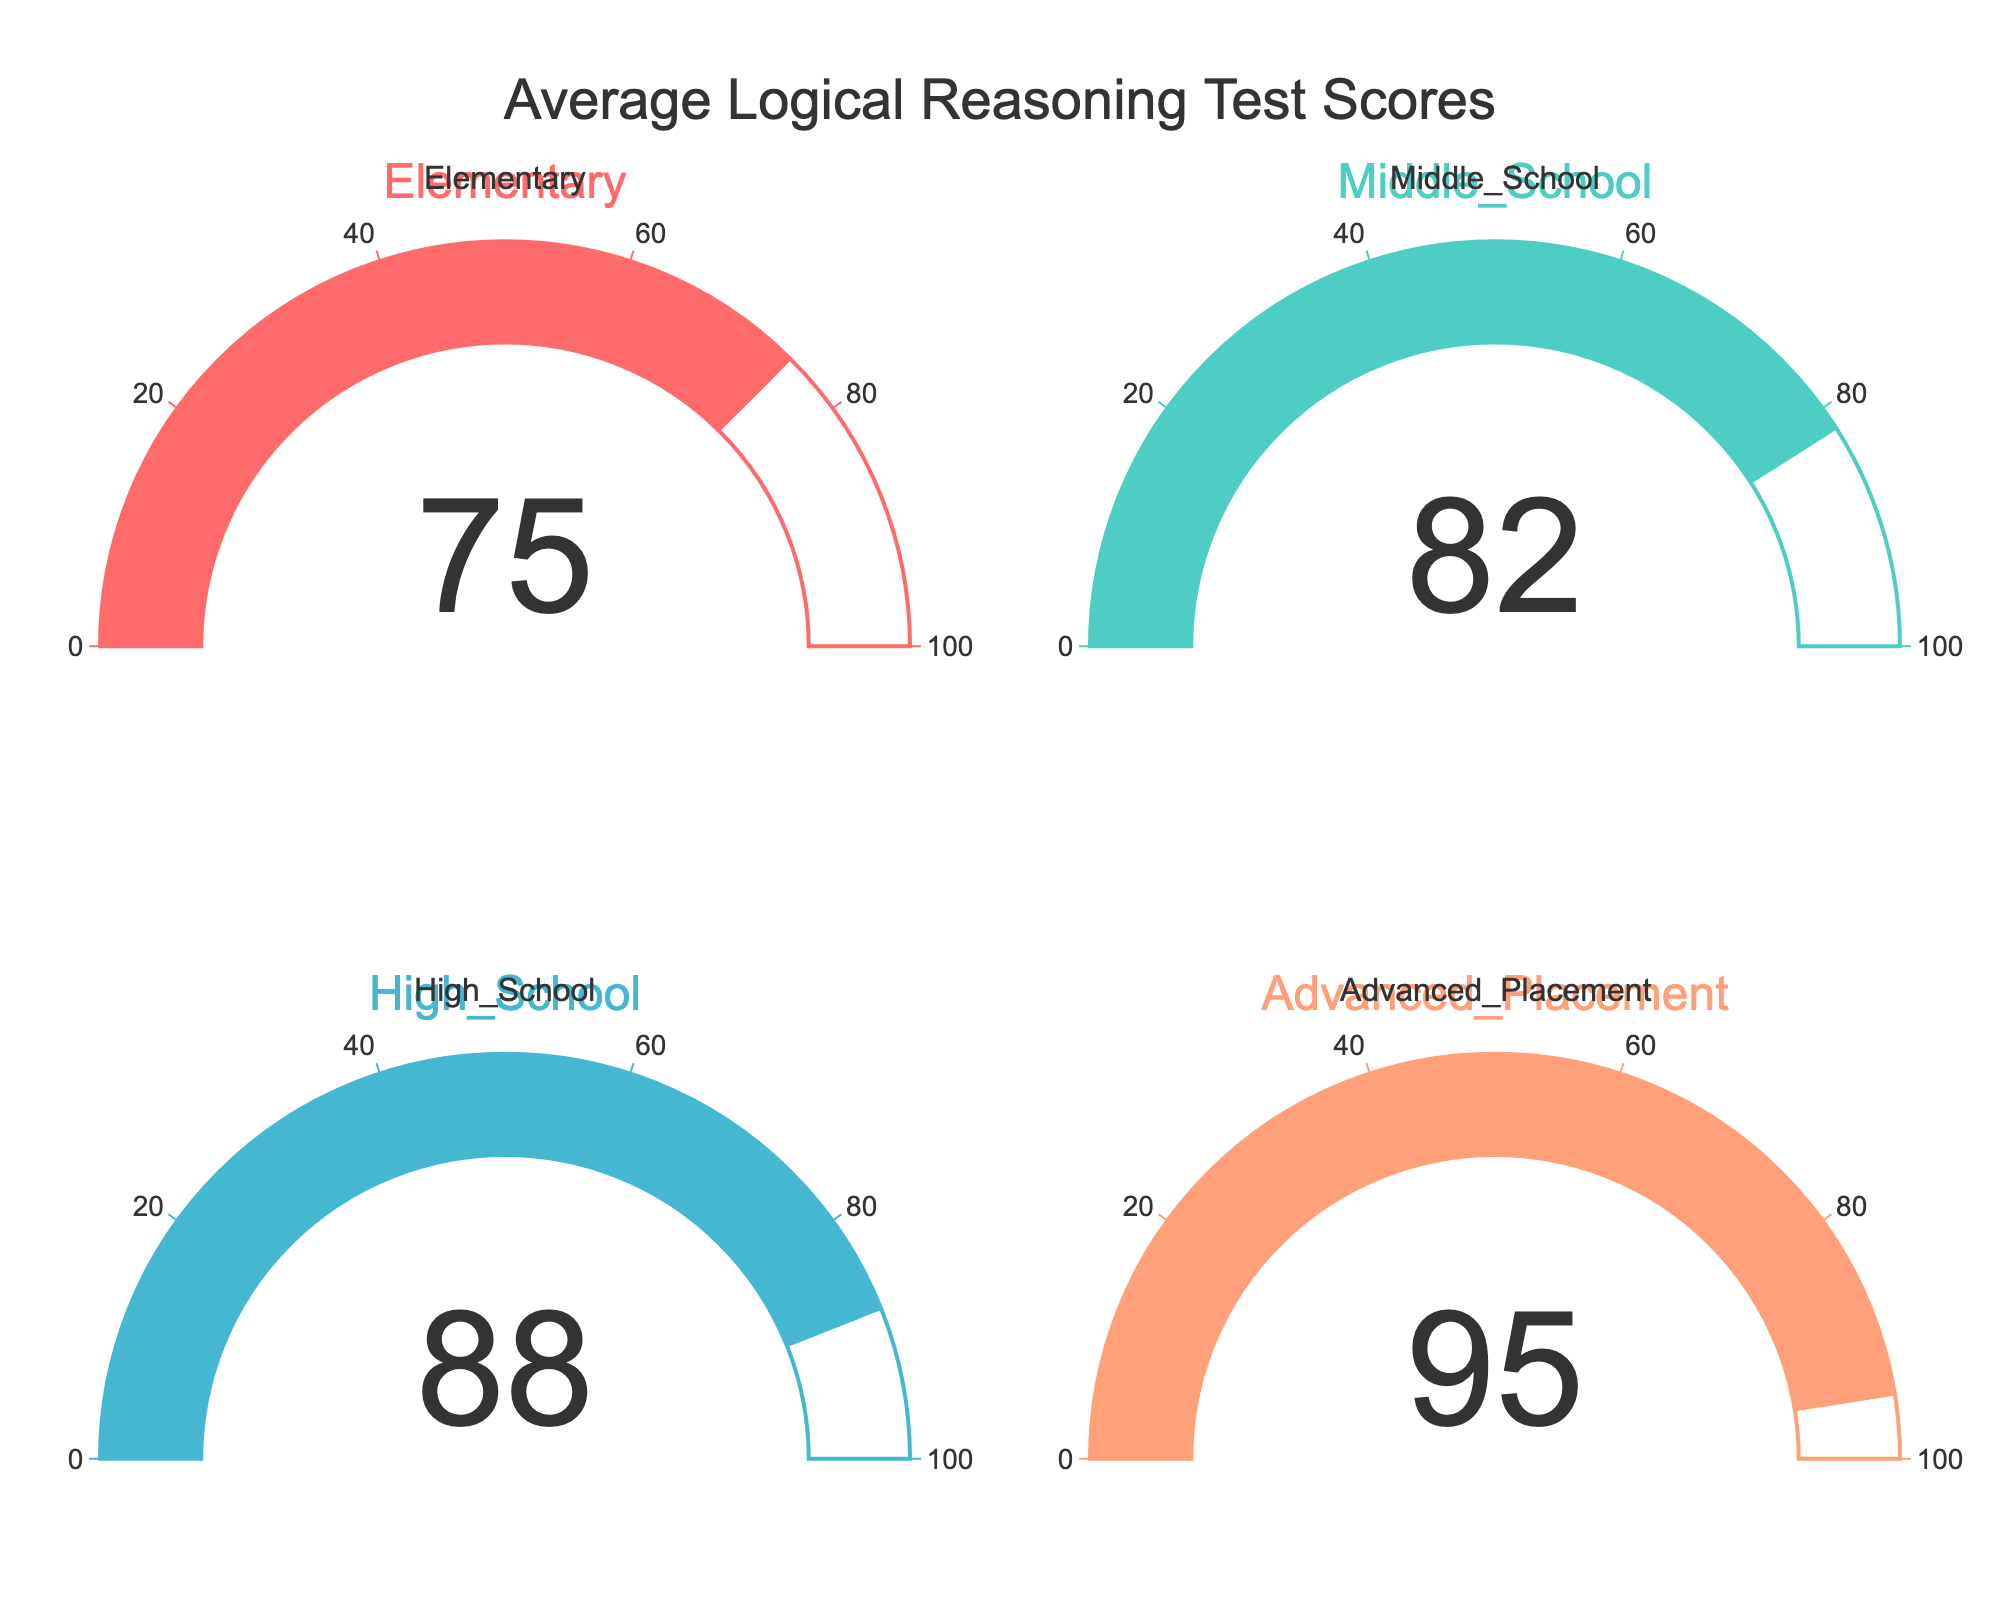What's the average score of the Elementary group? Look at the gauge chart labeled "Elementary." The value displayed on the gauge is the average score.
Answer: 75 Which group has the highest average score? Compare the values displayed on all gauges. The group with the highest value is the one with the highest average score.
Answer: Advanced Placement What's the total average score for all groups combined? Sum the average scores of all groups: 75 (Elementary) + 82 (Middle School) + 88 (High School) + 95 (Advanced Placement) = 340.
Answer: 340 How much higher is the Advanced Placement average score compared to the Elementary average score? Subtract the Elementary score from the Advanced Placement score: 95 - 75 = 20.
Answer: 20 Which group has a lower average score, Middle School or High School? Compare the values on the gauges for Middle School and High School. The Middle School gauge shows 82, and the High School gauge shows 88.
Answer: Middle School How does the average score for Middle School compare to that of Elementary? Subtract the Elementary score from the Middle School score: 82 - 75 = 7.
Answer: 7 What's the average of the High School and Advanced Placement scores? Sum the average scores of High School and Advanced Placement, then divide by 2: (88 + 95) / 2 = 91.5.
Answer: 91.5 What's the difference between the highest and lowest average scores in the figure? Subtract the lowest score (Elementary, 75) from the highest score (Advanced Placement, 95): 95 - 75 = 20.
Answer: 20 Which group has an average score closest to 90? Compare the displayed gauge values to 90 and find the closest one. High School has 88, which is closest to 90.
Answer: High School What percentage of the maximum possible score (100) did the High School group achieve? Divide the High School score by the maximum score and multiply by 100: (88 / 100) * 100 = 88%.
Answer: 88% 